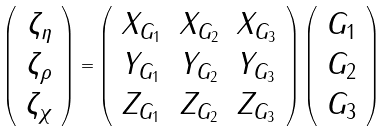Convert formula to latex. <formula><loc_0><loc_0><loc_500><loc_500>\left ( \begin{array} { c } \zeta _ { \eta } \\ \zeta _ { \rho } \\ \zeta _ { \chi } \end{array} \right ) = \left ( \begin{array} { c c c } X _ { G _ { 1 } } & X _ { G _ { 2 } } & X _ { G _ { 3 } } \\ Y _ { G _ { 1 } } & Y _ { G _ { 2 } } & Y _ { G _ { 3 } } \\ Z _ { G _ { 1 } } & Z _ { G _ { 2 } } & Z _ { G _ { 3 } } \end{array} \right ) \left ( \begin{array} { c } G _ { 1 } \\ G _ { 2 } \\ G _ { 3 } \end{array} \right )</formula> 